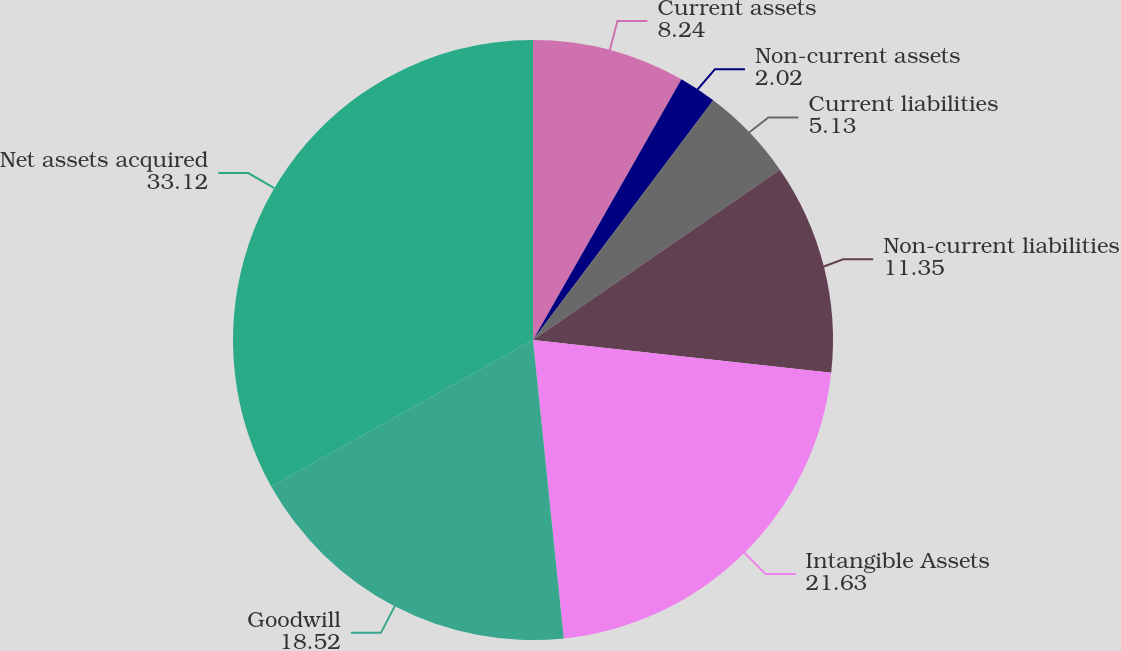Convert chart to OTSL. <chart><loc_0><loc_0><loc_500><loc_500><pie_chart><fcel>Current assets<fcel>Non-current assets<fcel>Current liabilities<fcel>Non-current liabilities<fcel>Intangible Assets<fcel>Goodwill<fcel>Net assets acquired<nl><fcel>8.24%<fcel>2.02%<fcel>5.13%<fcel>11.35%<fcel>21.63%<fcel>18.52%<fcel>33.12%<nl></chart> 